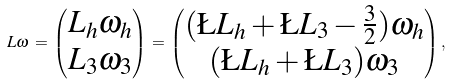Convert formula to latex. <formula><loc_0><loc_0><loc_500><loc_500>L \omega \, = \, \begin{pmatrix} L _ { h } \omega _ { h } \\ L _ { 3 } \omega _ { 3 } \end{pmatrix} \, = \, \begin{pmatrix} ( \L L _ { h } + \L L _ { 3 } - \frac { 3 } { 2 } ) \omega _ { h } \\ ( \L L _ { h } + \L L _ { 3 } ) \omega _ { 3 } \end{pmatrix} ,</formula> 